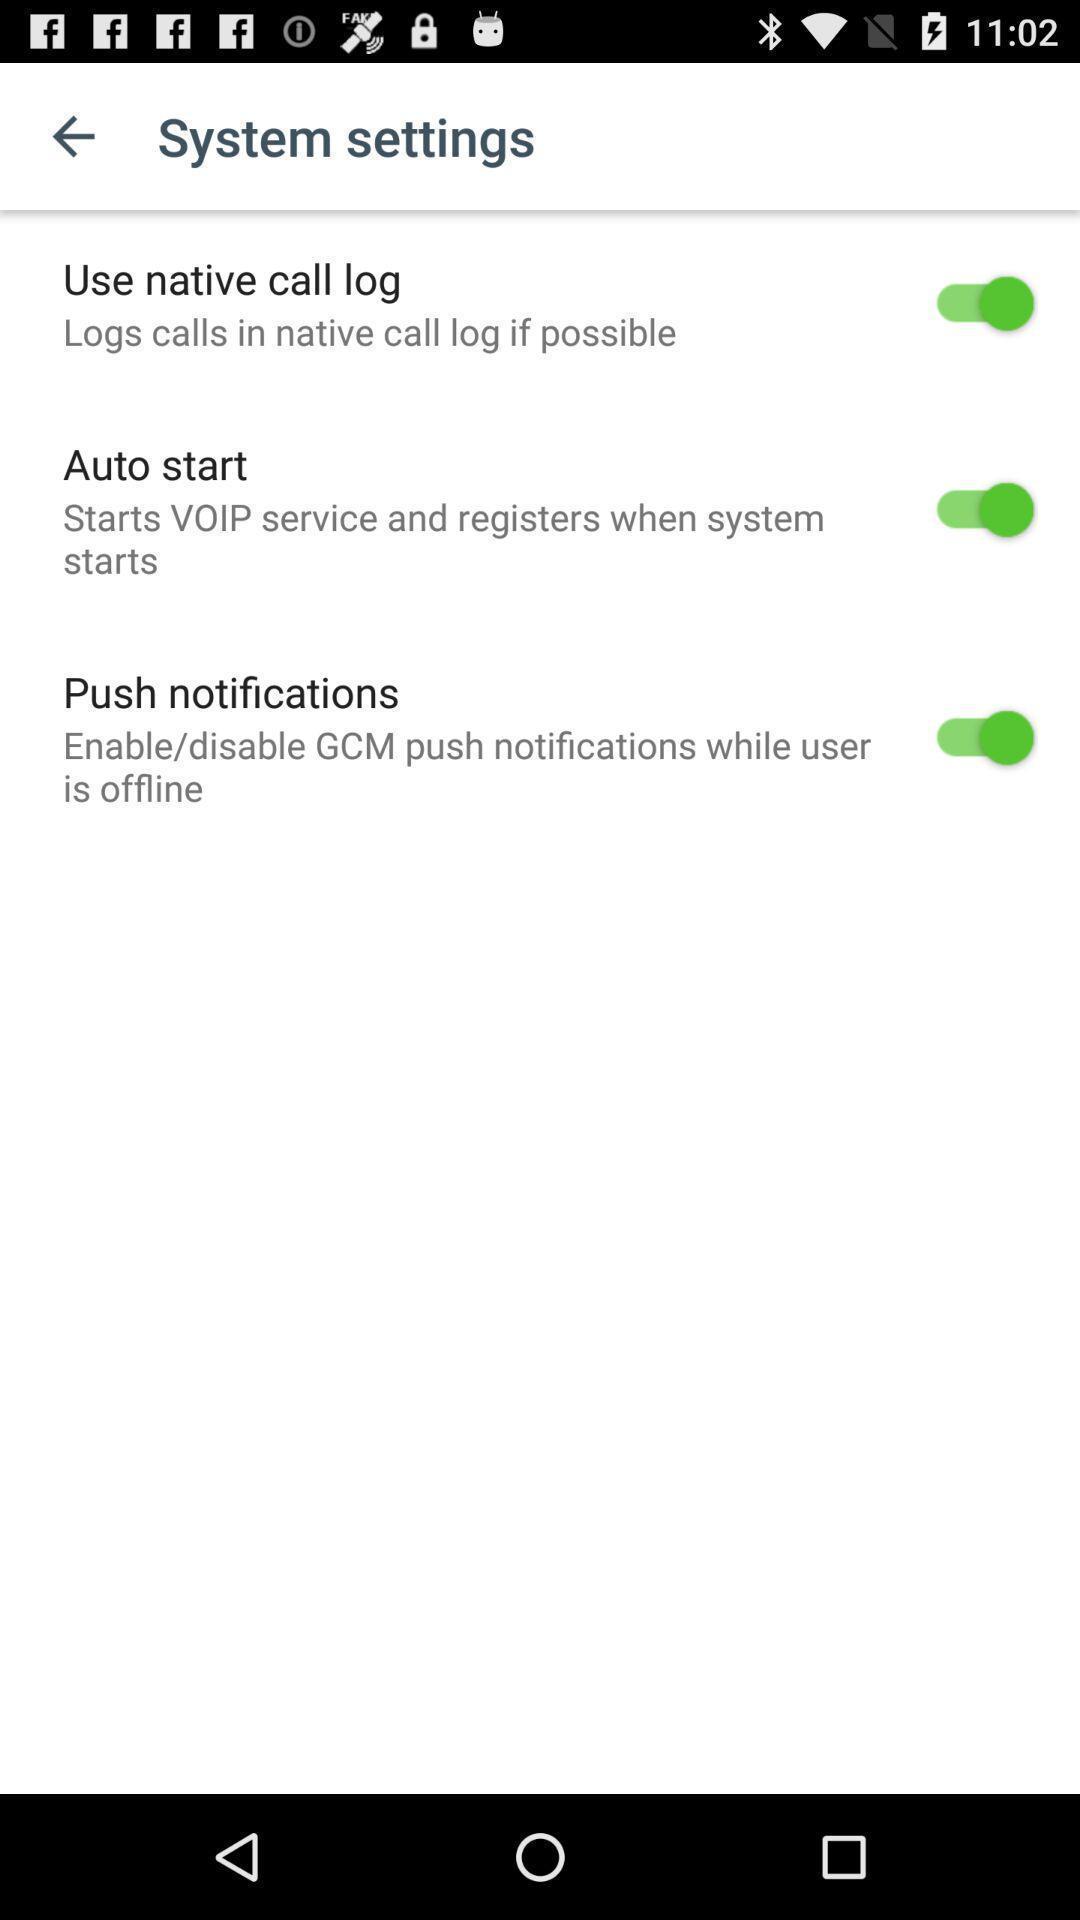Provide a detailed account of this screenshot. Settings page. 